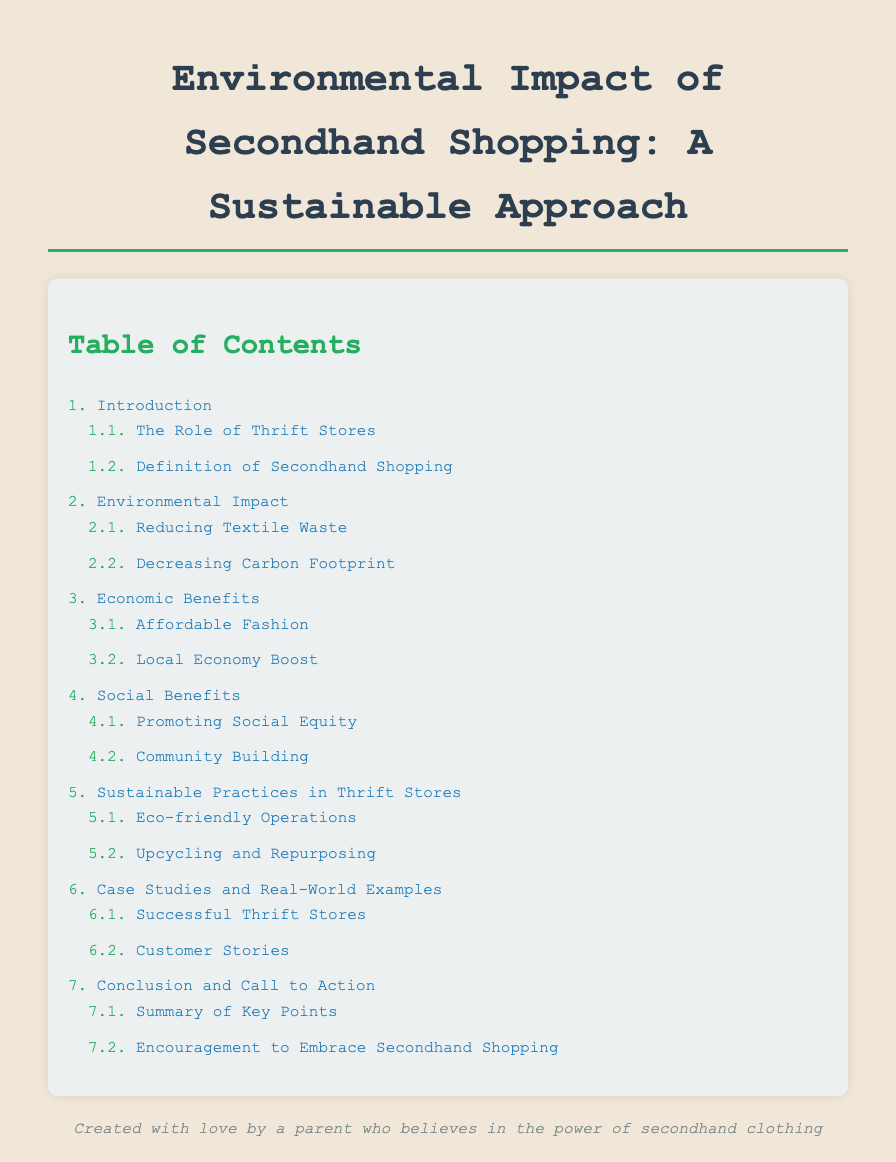What is the title of the document? The title of the document is prominently displayed at the top and states "Environmental Impact of Secondhand Shopping: A Sustainable Approach."
Answer: Environmental Impact of Secondhand Shopping: A Sustainable Approach How many main sections are in the Table of Contents? The main sections of the Table of Contents can be counted directly from the list of items, which shows a total of seven main sections.
Answer: 7 What is one benefit of secondhand shopping mentioned? The document lists multiple benefits, and one specific benefit can be found under the "Economic Benefits" section, such as "Affordable Fashion."
Answer: Affordable Fashion What section discusses promoting social equity? The section that covers this topic is found under "Social Benefits" within the Table of Contents.
Answer: Promoting Social Equity Which part of the document focuses on thrift store operations? The part that addresses this is titled "Sustainable Practices in Thrift Stores" in the Table of Contents.
Answer: Sustainable Practices in Thrift Stores What type of stories are included in the case studies? The case studies section includes a specific type of story that reflects customer experiences under the "Customer Stories" sub-section.
Answer: Customer Stories How is the document styled visually? The document is styled with specific colors, font choices, and layouts that create a structured and appealing look, as stated in the document's CSS styling.
Answer: Eco-friendly colors and structure 